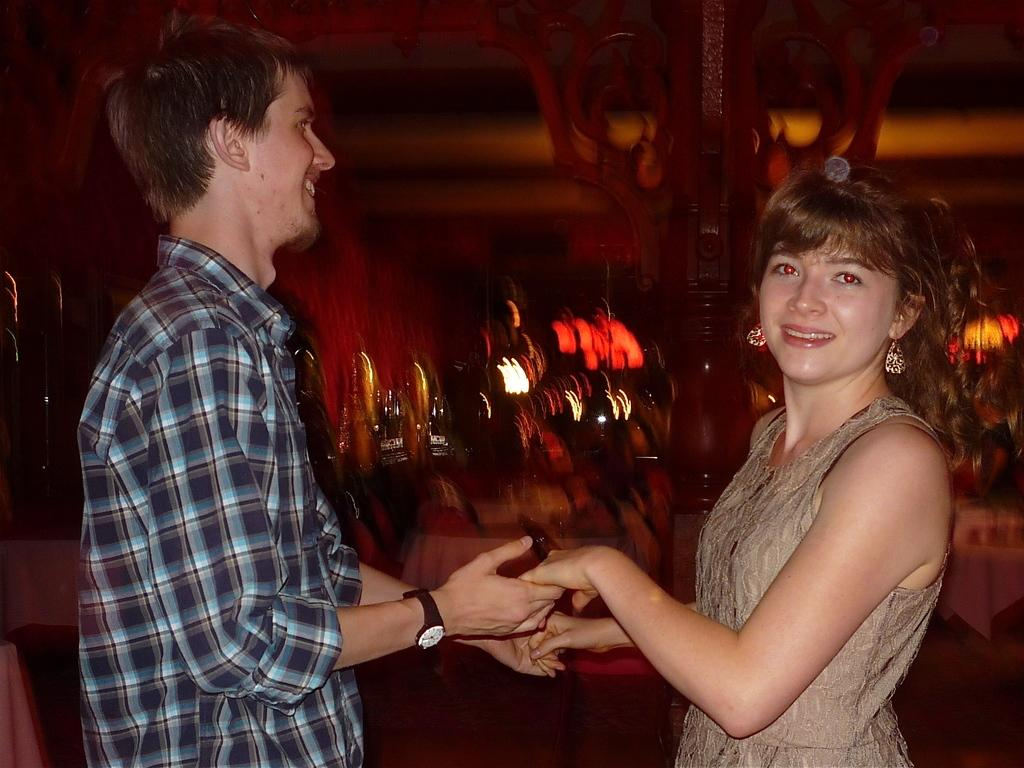How many people are in the image? There are two people in the image. What are the two people doing? The two people are holding hands. What color is the background of the image? The background of the image is in brown color. How would you describe the background's appearance? The background is blurred. What type of insect can be seen crawling on the team in the image? There is no team or insect present in the image. 